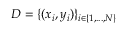<formula> <loc_0><loc_0><loc_500><loc_500>D = \{ ( x _ { i } , y _ { i } ) \} _ { i \in \{ 1 , \dots , N \} }</formula> 